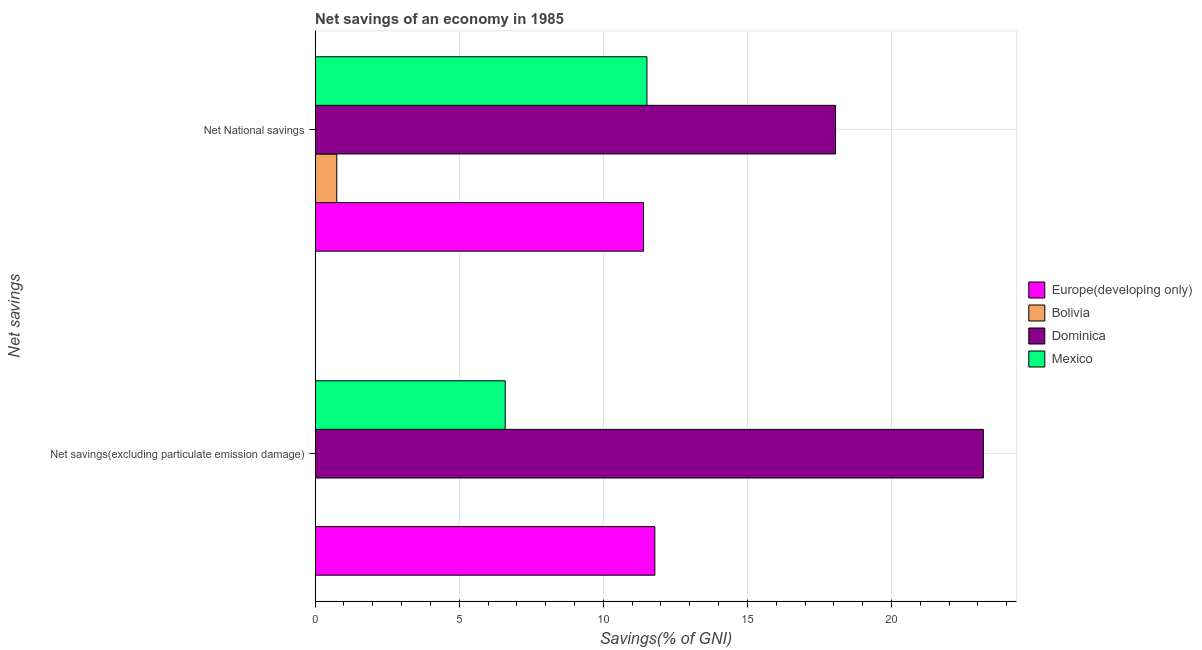How many groups of bars are there?
Your answer should be compact. 2. How many bars are there on the 2nd tick from the top?
Give a very brief answer. 3. How many bars are there on the 2nd tick from the bottom?
Make the answer very short. 4. What is the label of the 1st group of bars from the top?
Your answer should be compact. Net National savings. What is the net national savings in Dominica?
Provide a succinct answer. 18.06. Across all countries, what is the maximum net national savings?
Offer a terse response. 18.06. Across all countries, what is the minimum net national savings?
Provide a short and direct response. 0.75. In which country was the net national savings maximum?
Provide a succinct answer. Dominica. What is the total net savings(excluding particulate emission damage) in the graph?
Provide a short and direct response. 41.57. What is the difference between the net national savings in Mexico and that in Dominica?
Provide a short and direct response. -6.55. What is the difference between the net national savings in Dominica and the net savings(excluding particulate emission damage) in Bolivia?
Keep it short and to the point. 18.06. What is the average net national savings per country?
Your response must be concise. 10.43. What is the difference between the net national savings and net savings(excluding particulate emission damage) in Mexico?
Make the answer very short. 4.92. What is the ratio of the net savings(excluding particulate emission damage) in Europe(developing only) to that in Mexico?
Keep it short and to the point. 1.79. How many bars are there?
Make the answer very short. 7. Are all the bars in the graph horizontal?
Give a very brief answer. Yes. How many countries are there in the graph?
Offer a terse response. 4. What is the difference between two consecutive major ticks on the X-axis?
Make the answer very short. 5. Does the graph contain any zero values?
Your response must be concise. Yes. Does the graph contain grids?
Give a very brief answer. Yes. What is the title of the graph?
Provide a short and direct response. Net savings of an economy in 1985. What is the label or title of the X-axis?
Your answer should be compact. Savings(% of GNI). What is the label or title of the Y-axis?
Provide a succinct answer. Net savings. What is the Savings(% of GNI) in Europe(developing only) in Net savings(excluding particulate emission damage)?
Ensure brevity in your answer.  11.79. What is the Savings(% of GNI) of Bolivia in Net savings(excluding particulate emission damage)?
Make the answer very short. 0. What is the Savings(% of GNI) in Dominica in Net savings(excluding particulate emission damage)?
Offer a terse response. 23.19. What is the Savings(% of GNI) in Mexico in Net savings(excluding particulate emission damage)?
Your answer should be compact. 6.6. What is the Savings(% of GNI) of Europe(developing only) in Net National savings?
Keep it short and to the point. 11.4. What is the Savings(% of GNI) in Bolivia in Net National savings?
Your response must be concise. 0.75. What is the Savings(% of GNI) of Dominica in Net National savings?
Your answer should be very brief. 18.06. What is the Savings(% of GNI) of Mexico in Net National savings?
Provide a short and direct response. 11.51. Across all Net savings, what is the maximum Savings(% of GNI) of Europe(developing only)?
Your answer should be compact. 11.79. Across all Net savings, what is the maximum Savings(% of GNI) in Bolivia?
Ensure brevity in your answer.  0.75. Across all Net savings, what is the maximum Savings(% of GNI) in Dominica?
Keep it short and to the point. 23.19. Across all Net savings, what is the maximum Savings(% of GNI) of Mexico?
Offer a terse response. 11.51. Across all Net savings, what is the minimum Savings(% of GNI) in Europe(developing only)?
Provide a short and direct response. 11.4. Across all Net savings, what is the minimum Savings(% of GNI) of Bolivia?
Provide a succinct answer. 0. Across all Net savings, what is the minimum Savings(% of GNI) of Dominica?
Give a very brief answer. 18.06. Across all Net savings, what is the minimum Savings(% of GNI) of Mexico?
Your answer should be compact. 6.6. What is the total Savings(% of GNI) in Europe(developing only) in the graph?
Ensure brevity in your answer.  23.19. What is the total Savings(% of GNI) of Bolivia in the graph?
Give a very brief answer. 0.75. What is the total Savings(% of GNI) in Dominica in the graph?
Your response must be concise. 41.25. What is the total Savings(% of GNI) in Mexico in the graph?
Make the answer very short. 18.11. What is the difference between the Savings(% of GNI) of Europe(developing only) in Net savings(excluding particulate emission damage) and that in Net National savings?
Offer a terse response. 0.39. What is the difference between the Savings(% of GNI) of Dominica in Net savings(excluding particulate emission damage) and that in Net National savings?
Offer a very short reply. 5.13. What is the difference between the Savings(% of GNI) in Mexico in Net savings(excluding particulate emission damage) and that in Net National savings?
Provide a succinct answer. -4.92. What is the difference between the Savings(% of GNI) of Europe(developing only) in Net savings(excluding particulate emission damage) and the Savings(% of GNI) of Bolivia in Net National savings?
Make the answer very short. 11.04. What is the difference between the Savings(% of GNI) in Europe(developing only) in Net savings(excluding particulate emission damage) and the Savings(% of GNI) in Dominica in Net National savings?
Your answer should be very brief. -6.27. What is the difference between the Savings(% of GNI) in Europe(developing only) in Net savings(excluding particulate emission damage) and the Savings(% of GNI) in Mexico in Net National savings?
Provide a short and direct response. 0.28. What is the difference between the Savings(% of GNI) in Dominica in Net savings(excluding particulate emission damage) and the Savings(% of GNI) in Mexico in Net National savings?
Provide a short and direct response. 11.67. What is the average Savings(% of GNI) in Europe(developing only) per Net savings?
Your answer should be compact. 11.59. What is the average Savings(% of GNI) in Bolivia per Net savings?
Your answer should be compact. 0.38. What is the average Savings(% of GNI) in Dominica per Net savings?
Give a very brief answer. 20.62. What is the average Savings(% of GNI) in Mexico per Net savings?
Offer a very short reply. 9.06. What is the difference between the Savings(% of GNI) in Europe(developing only) and Savings(% of GNI) in Dominica in Net savings(excluding particulate emission damage)?
Make the answer very short. -11.4. What is the difference between the Savings(% of GNI) in Europe(developing only) and Savings(% of GNI) in Mexico in Net savings(excluding particulate emission damage)?
Your answer should be very brief. 5.19. What is the difference between the Savings(% of GNI) in Dominica and Savings(% of GNI) in Mexico in Net savings(excluding particulate emission damage)?
Provide a short and direct response. 16.59. What is the difference between the Savings(% of GNI) of Europe(developing only) and Savings(% of GNI) of Bolivia in Net National savings?
Your response must be concise. 10.64. What is the difference between the Savings(% of GNI) in Europe(developing only) and Savings(% of GNI) in Dominica in Net National savings?
Offer a terse response. -6.66. What is the difference between the Savings(% of GNI) of Europe(developing only) and Savings(% of GNI) of Mexico in Net National savings?
Keep it short and to the point. -0.12. What is the difference between the Savings(% of GNI) in Bolivia and Savings(% of GNI) in Dominica in Net National savings?
Your answer should be very brief. -17.31. What is the difference between the Savings(% of GNI) in Bolivia and Savings(% of GNI) in Mexico in Net National savings?
Offer a very short reply. -10.76. What is the difference between the Savings(% of GNI) in Dominica and Savings(% of GNI) in Mexico in Net National savings?
Offer a very short reply. 6.55. What is the ratio of the Savings(% of GNI) of Europe(developing only) in Net savings(excluding particulate emission damage) to that in Net National savings?
Offer a very short reply. 1.03. What is the ratio of the Savings(% of GNI) in Dominica in Net savings(excluding particulate emission damage) to that in Net National savings?
Offer a very short reply. 1.28. What is the ratio of the Savings(% of GNI) in Mexico in Net savings(excluding particulate emission damage) to that in Net National savings?
Your response must be concise. 0.57. What is the difference between the highest and the second highest Savings(% of GNI) of Europe(developing only)?
Make the answer very short. 0.39. What is the difference between the highest and the second highest Savings(% of GNI) in Dominica?
Provide a short and direct response. 5.13. What is the difference between the highest and the second highest Savings(% of GNI) in Mexico?
Give a very brief answer. 4.92. What is the difference between the highest and the lowest Savings(% of GNI) of Europe(developing only)?
Your answer should be very brief. 0.39. What is the difference between the highest and the lowest Savings(% of GNI) of Bolivia?
Keep it short and to the point. 0.75. What is the difference between the highest and the lowest Savings(% of GNI) in Dominica?
Offer a very short reply. 5.13. What is the difference between the highest and the lowest Savings(% of GNI) in Mexico?
Keep it short and to the point. 4.92. 